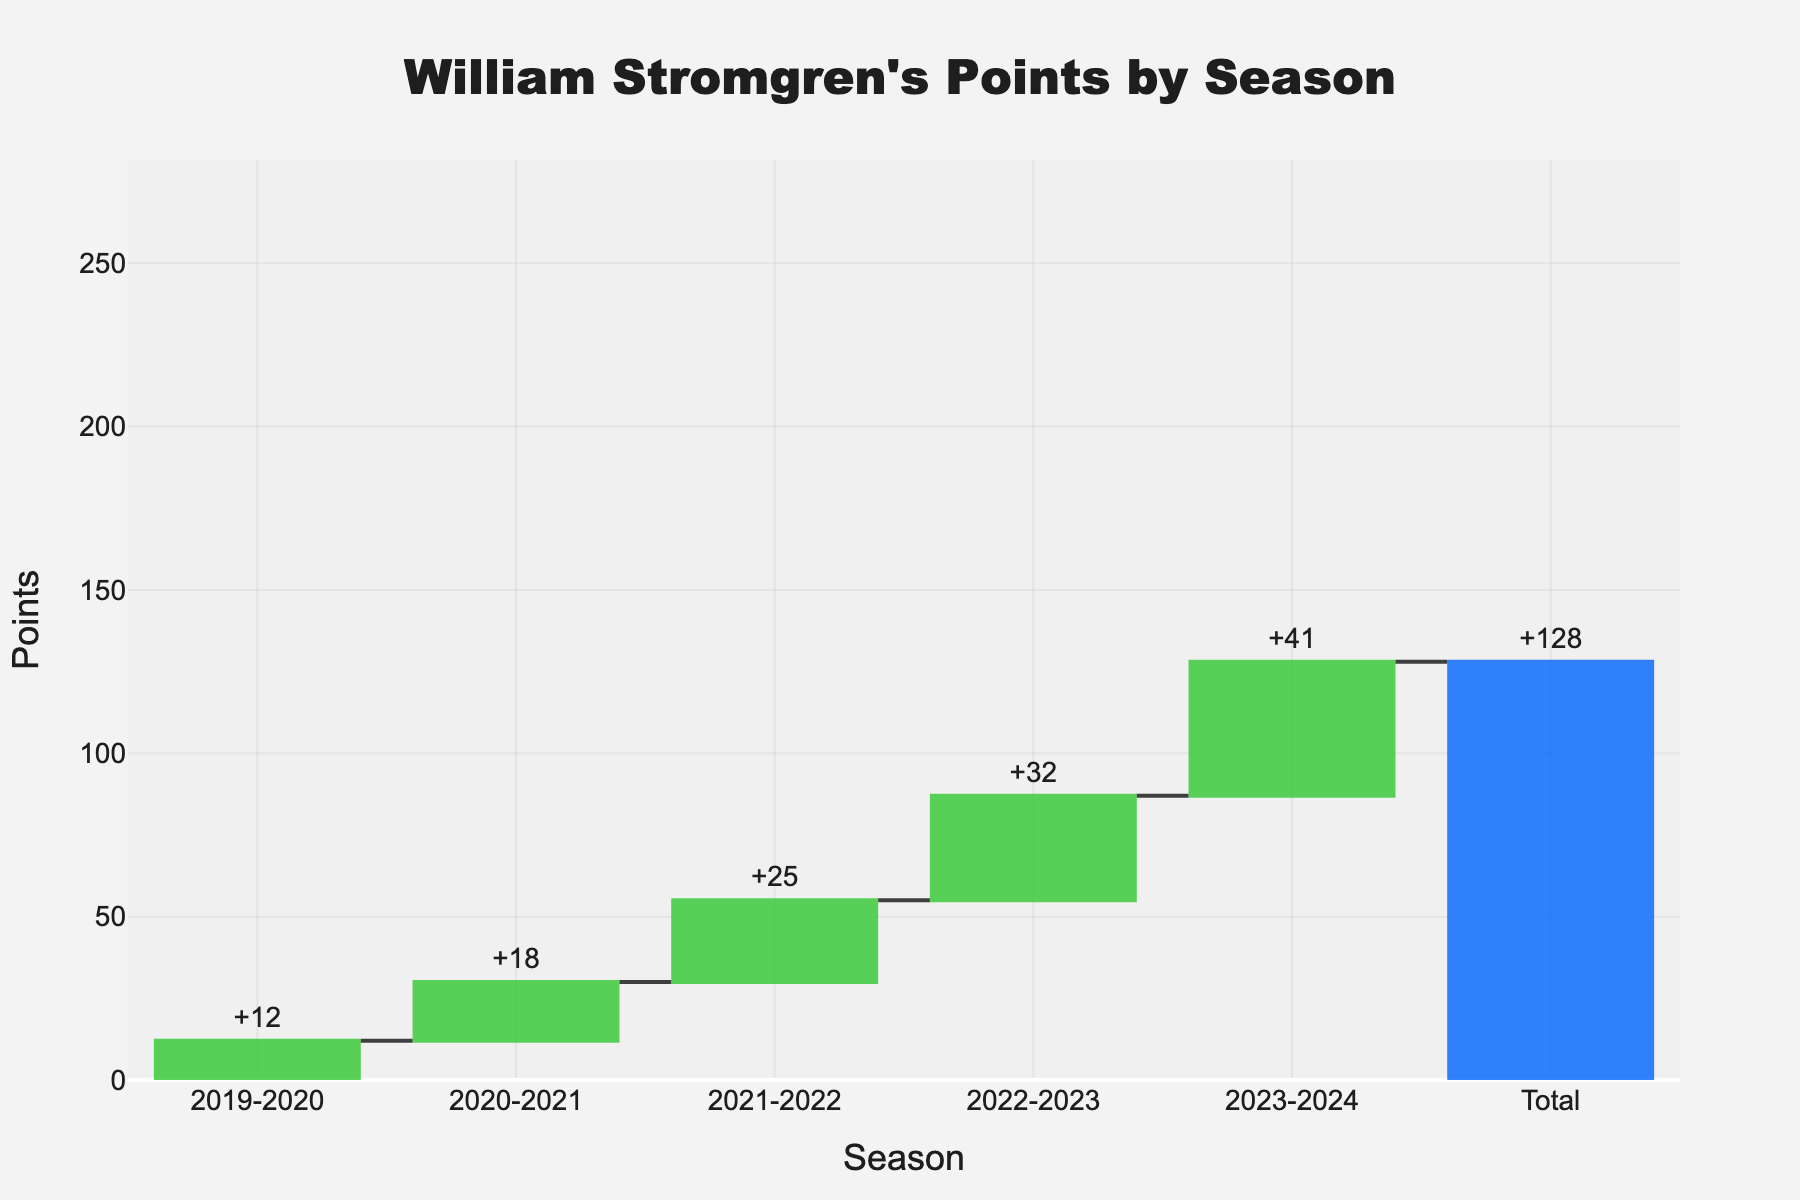What's the overall title of the figure? The overall title is placed at the top of the figure and is clearly readable. It typically summarizes the contents of the chart.
Answer: William Stromgren's Points by Season Which season shows the highest increase in points? To find the highest increase, look for the tallest bar among the seasons. The season 2023-2024 has the highest bar showing +41 points.
Answer: 2023-2024 How many total points did William Stromgren accumulate over the seasons? The total points are shown in the last bar of the waterfall chart, which represents the sum of all previous seasons. The total is 128.
Answer: 128 By how many points did William Stromgren's points increase from the 2021-2022 season to the 2022-2023 season? First identify the points in 2021-2022 (+25) and in 2022-2023 (+32). The difference is calculated as 32 - 25.
Answer: 7 What is the average points increase per season over the four seasons? To calculate the average increase, sum the individual season increases (+18, +25, +32, +41) and divide by the number of seasons (4). (18 + 25 + 32 + 41) / 4 = 116 / 4.
Answer: 29 Compare the points increase from the 2019-2020 to 2020-2021 season and the 2020-2021 to 2021-2022 season. Which was greater? Compare the height of the bars for each season’s increase. From 2019-2020 to 2020-2021 the increase is +18, and from 2020-2021 to 2021-2022 it is +25. Since 25 > 18, the second one is greater.
Answer: 2020-2021 to 2021-2022 What colors are used to represent the increasing and total points in the chart? Identify the colors coded in the chart for increasing points and the total. Increasing points are represented in green and total points in blue.
Answer: Green and blue What is the difference in points between the season with the lowest increase and the season with the highest increase? The lowest increase is in 2019-2020 (+12), and the highest is in 2023-2024 (+41). Calculate the difference: 41 - 12.
Answer: 29 Which seasons had an increase greater than 30 points? Identify the bars with heights greater than 30 points. The seasons are 2022-2023 (+32) and 2023-2024 (+41).
Answer: 2022-2023 and 2023-2024 What category/measure is used for the total in the waterfall chart? The measure for the total, typically indicated at the last position in a waterfall chart, is usually labeled as 'total'.
Answer: total 